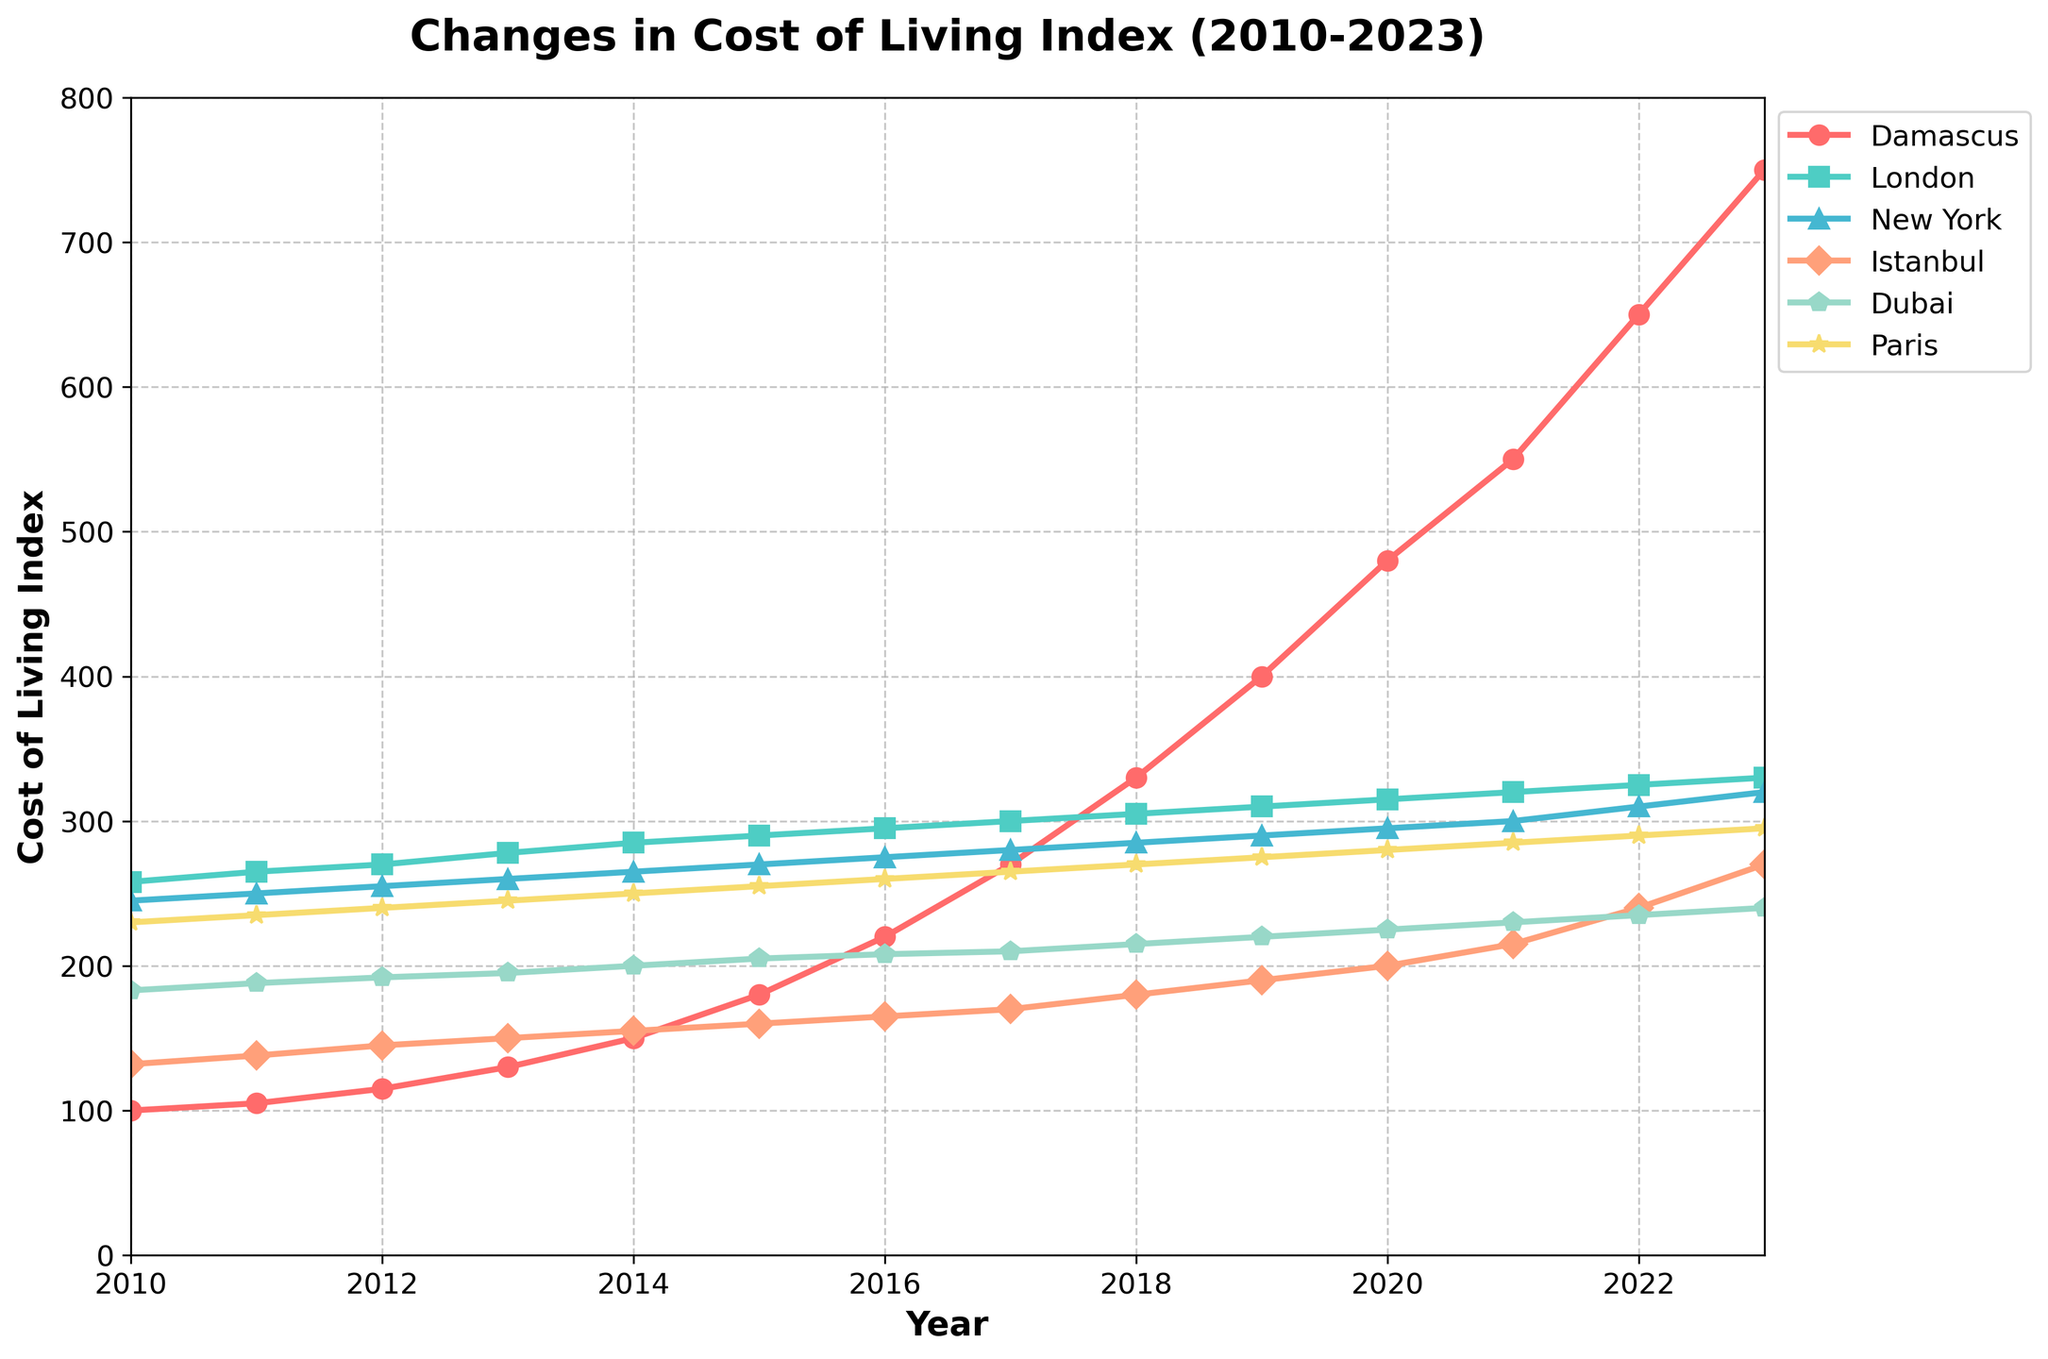What is the cost of living index for Damascus in 2020? Look at the line plot for Damascus and find the value at the year 2020. The label on the y-axis that corresponds to this point will give the cost of living index.
Answer: 480 How much did the cost of living index for New York increase from 2010 to 2023? Find the values for New York at the years 2010 and 2023 on the y-axis. Subtract the 2010 value from the 2023 value.
Answer: 75 Which city had the highest cost of living index in 2018? Look at the line plots for all cities for the year 2018 and find which one corresponds to the highest value on the y-axis.
Answer: New York Between which two consecutive years did Istanbul see the largest increase in the cost of living index? Compare the yearly increments of the index for Istanbul by subtracting the index of each year from the next across all years. Identify the years with the largest difference.
Answer: 2021-2022 What is the trend of the cost of living index for Damascus from 2010 to 2023? Observe the overall pattern of the line plot for Damascus from 2010 to 2023. The trend shows whether it is increasing, decreasing, or stable over time.
Answer: Increasing How many cities had a cost of living index greater than 300 in 2023? Check the y-axis values for all the cities in the year 2023 and count how many of these values are greater than 300.
Answer: 3 In which year did London surpass a cost of living index of 300? Look at the line plot for London and find the year where the plot line crosses the 300 mark on the y-axis.
Answer: 2018 What is the average cost of living index for Dubai over the given period? Sum the cost of living index values for Dubai for all years from 2010 to 2023 and divide by the number of years (14).
Answer: 211.5 Which city had the smallest variance in cost of living index from 2010 to 2023? Compare the range (difference between max and min) of the cost of living index of all the cities from 2010 to 2023 and identify the city with the smallest range.
Answer: London If you calculate the difference in the cost of living index between Paris and Damascus in 2023, what is it? Subtract the cost of living index of Damascus from the cost of living index of Paris for the year 2023.
Answer: -455 